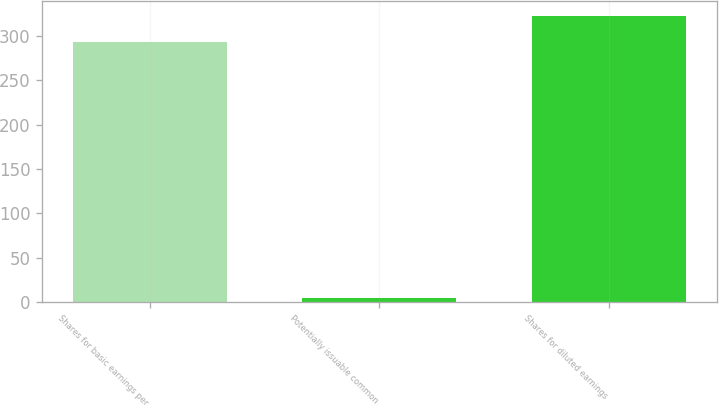Convert chart. <chart><loc_0><loc_0><loc_500><loc_500><bar_chart><fcel>Shares for basic earnings per<fcel>Potentially issuable common<fcel>Shares for diluted earnings<nl><fcel>293.4<fcel>4.7<fcel>322.74<nl></chart> 